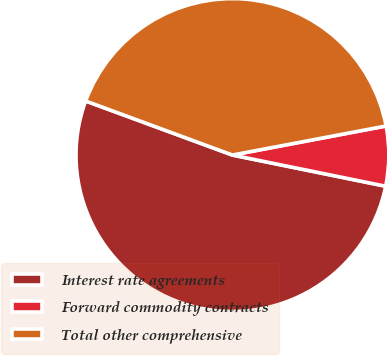Convert chart to OTSL. <chart><loc_0><loc_0><loc_500><loc_500><pie_chart><fcel>Interest rate agreements<fcel>Forward commodity contracts<fcel>Total other comprehensive<nl><fcel>52.42%<fcel>6.17%<fcel>41.41%<nl></chart> 